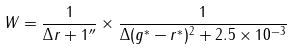Convert formula to latex. <formula><loc_0><loc_0><loc_500><loc_500>W = \frac { 1 } { \Delta r + 1 ^ { \prime \prime } } \times \frac { 1 } { \Delta ( g ^ { * } - r ^ { * } ) ^ { 2 } + 2 . 5 \times 1 0 ^ { - 3 } }</formula> 